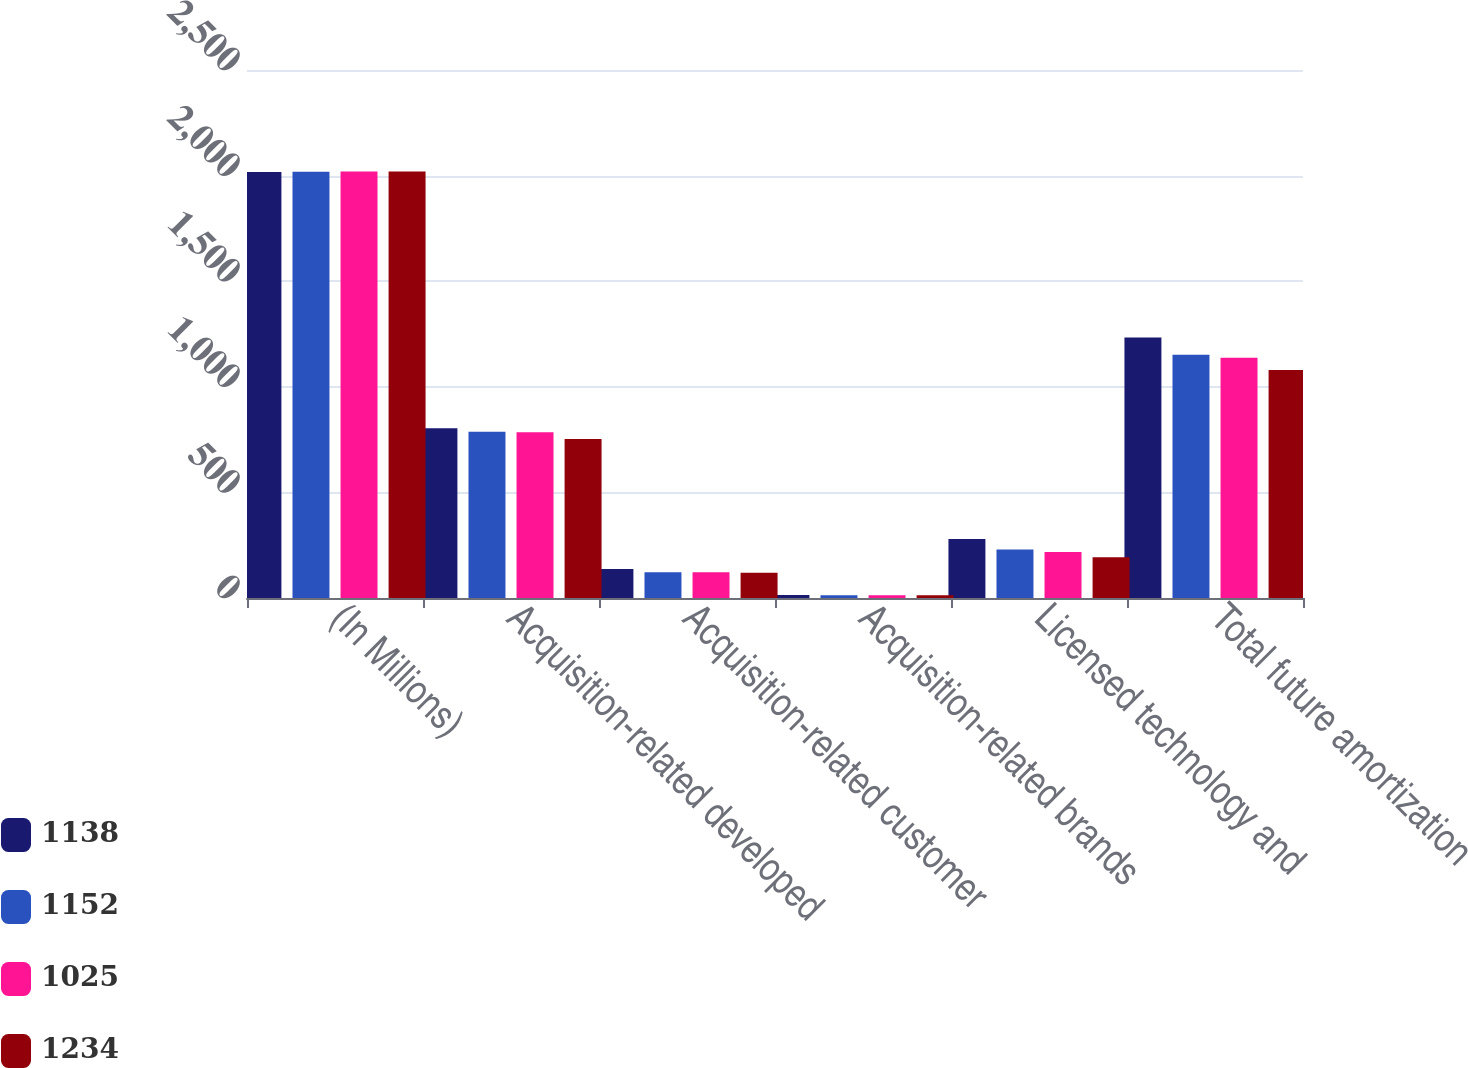Convert chart. <chart><loc_0><loc_0><loc_500><loc_500><stacked_bar_chart><ecel><fcel>(In Millions)<fcel>Acquisition-related developed<fcel>Acquisition-related customer<fcel>Acquisition-related brands<fcel>Licensed technology and<fcel>Total future amortization<nl><fcel>1138<fcel>2017<fcel>804<fcel>137<fcel>14<fcel>279<fcel>1234<nl><fcel>1152<fcel>2018<fcel>787<fcel>122<fcel>13<fcel>230<fcel>1152<nl><fcel>1025<fcel>2019<fcel>785<fcel>122<fcel>13<fcel>218<fcel>1138<nl><fcel>1234<fcel>2020<fcel>753<fcel>120<fcel>13<fcel>193<fcel>1079<nl></chart> 